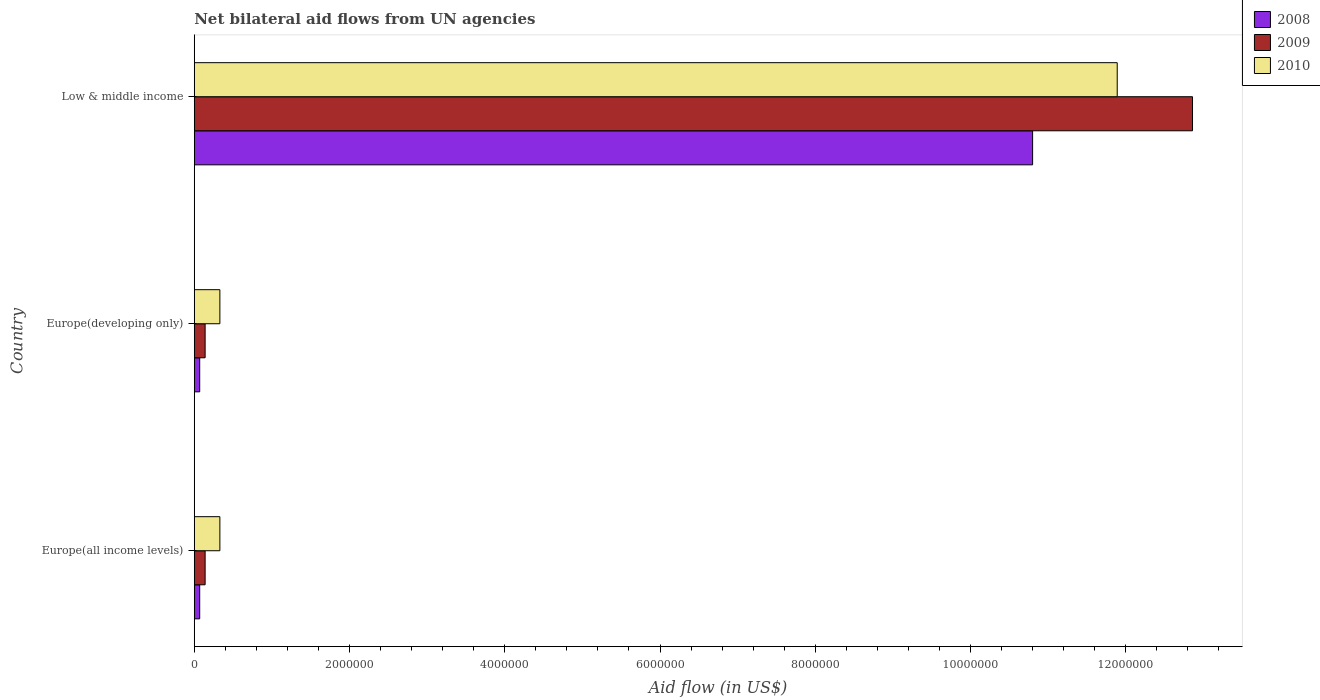Are the number of bars on each tick of the Y-axis equal?
Your answer should be compact. Yes. How many bars are there on the 1st tick from the bottom?
Provide a succinct answer. 3. What is the label of the 2nd group of bars from the top?
Keep it short and to the point. Europe(developing only). Across all countries, what is the maximum net bilateral aid flow in 2008?
Give a very brief answer. 1.08e+07. Across all countries, what is the minimum net bilateral aid flow in 2010?
Your answer should be compact. 3.30e+05. In which country was the net bilateral aid flow in 2009 minimum?
Offer a terse response. Europe(all income levels). What is the total net bilateral aid flow in 2009 in the graph?
Provide a short and direct response. 1.31e+07. What is the difference between the net bilateral aid flow in 2010 in Europe(developing only) and that in Low & middle income?
Make the answer very short. -1.16e+07. What is the difference between the net bilateral aid flow in 2008 in Europe(all income levels) and the net bilateral aid flow in 2009 in Low & middle income?
Offer a very short reply. -1.28e+07. What is the average net bilateral aid flow in 2009 per country?
Provide a succinct answer. 4.38e+06. What is the difference between the net bilateral aid flow in 2008 and net bilateral aid flow in 2010 in Low & middle income?
Ensure brevity in your answer.  -1.09e+06. In how many countries, is the net bilateral aid flow in 2009 greater than 11200000 US$?
Ensure brevity in your answer.  1. What is the ratio of the net bilateral aid flow in 2008 in Europe(all income levels) to that in Low & middle income?
Give a very brief answer. 0.01. Is the net bilateral aid flow in 2010 in Europe(all income levels) less than that in Low & middle income?
Keep it short and to the point. Yes. What is the difference between the highest and the second highest net bilateral aid flow in 2008?
Your answer should be very brief. 1.07e+07. What is the difference between the highest and the lowest net bilateral aid flow in 2009?
Provide a short and direct response. 1.27e+07. Is it the case that in every country, the sum of the net bilateral aid flow in 2010 and net bilateral aid flow in 2008 is greater than the net bilateral aid flow in 2009?
Give a very brief answer. Yes. Are all the bars in the graph horizontal?
Make the answer very short. Yes. Does the graph contain any zero values?
Your response must be concise. No. Where does the legend appear in the graph?
Provide a short and direct response. Top right. What is the title of the graph?
Keep it short and to the point. Net bilateral aid flows from UN agencies. What is the label or title of the X-axis?
Your answer should be compact. Aid flow (in US$). What is the label or title of the Y-axis?
Offer a very short reply. Country. What is the Aid flow (in US$) of 2008 in Europe(all income levels)?
Offer a very short reply. 7.00e+04. What is the Aid flow (in US$) of 2009 in Europe(all income levels)?
Offer a very short reply. 1.40e+05. What is the Aid flow (in US$) in 2010 in Europe(all income levels)?
Provide a succinct answer. 3.30e+05. What is the Aid flow (in US$) in 2009 in Europe(developing only)?
Give a very brief answer. 1.40e+05. What is the Aid flow (in US$) in 2010 in Europe(developing only)?
Make the answer very short. 3.30e+05. What is the Aid flow (in US$) in 2008 in Low & middle income?
Your response must be concise. 1.08e+07. What is the Aid flow (in US$) in 2009 in Low & middle income?
Make the answer very short. 1.29e+07. What is the Aid flow (in US$) of 2010 in Low & middle income?
Your answer should be very brief. 1.19e+07. Across all countries, what is the maximum Aid flow (in US$) in 2008?
Offer a terse response. 1.08e+07. Across all countries, what is the maximum Aid flow (in US$) of 2009?
Ensure brevity in your answer.  1.29e+07. Across all countries, what is the maximum Aid flow (in US$) in 2010?
Give a very brief answer. 1.19e+07. Across all countries, what is the minimum Aid flow (in US$) in 2010?
Offer a very short reply. 3.30e+05. What is the total Aid flow (in US$) in 2008 in the graph?
Offer a very short reply. 1.09e+07. What is the total Aid flow (in US$) of 2009 in the graph?
Give a very brief answer. 1.31e+07. What is the total Aid flow (in US$) in 2010 in the graph?
Offer a terse response. 1.26e+07. What is the difference between the Aid flow (in US$) in 2009 in Europe(all income levels) and that in Europe(developing only)?
Offer a very short reply. 0. What is the difference between the Aid flow (in US$) of 2008 in Europe(all income levels) and that in Low & middle income?
Your answer should be compact. -1.07e+07. What is the difference between the Aid flow (in US$) in 2009 in Europe(all income levels) and that in Low & middle income?
Keep it short and to the point. -1.27e+07. What is the difference between the Aid flow (in US$) in 2010 in Europe(all income levels) and that in Low & middle income?
Offer a terse response. -1.16e+07. What is the difference between the Aid flow (in US$) of 2008 in Europe(developing only) and that in Low & middle income?
Your response must be concise. -1.07e+07. What is the difference between the Aid flow (in US$) in 2009 in Europe(developing only) and that in Low & middle income?
Ensure brevity in your answer.  -1.27e+07. What is the difference between the Aid flow (in US$) of 2010 in Europe(developing only) and that in Low & middle income?
Your response must be concise. -1.16e+07. What is the difference between the Aid flow (in US$) of 2008 in Europe(all income levels) and the Aid flow (in US$) of 2009 in Europe(developing only)?
Provide a short and direct response. -7.00e+04. What is the difference between the Aid flow (in US$) of 2008 in Europe(all income levels) and the Aid flow (in US$) of 2010 in Europe(developing only)?
Provide a short and direct response. -2.60e+05. What is the difference between the Aid flow (in US$) of 2008 in Europe(all income levels) and the Aid flow (in US$) of 2009 in Low & middle income?
Offer a very short reply. -1.28e+07. What is the difference between the Aid flow (in US$) in 2008 in Europe(all income levels) and the Aid flow (in US$) in 2010 in Low & middle income?
Your answer should be very brief. -1.18e+07. What is the difference between the Aid flow (in US$) in 2009 in Europe(all income levels) and the Aid flow (in US$) in 2010 in Low & middle income?
Your answer should be very brief. -1.18e+07. What is the difference between the Aid flow (in US$) of 2008 in Europe(developing only) and the Aid flow (in US$) of 2009 in Low & middle income?
Provide a short and direct response. -1.28e+07. What is the difference between the Aid flow (in US$) in 2008 in Europe(developing only) and the Aid flow (in US$) in 2010 in Low & middle income?
Provide a short and direct response. -1.18e+07. What is the difference between the Aid flow (in US$) in 2009 in Europe(developing only) and the Aid flow (in US$) in 2010 in Low & middle income?
Ensure brevity in your answer.  -1.18e+07. What is the average Aid flow (in US$) in 2008 per country?
Your answer should be compact. 3.65e+06. What is the average Aid flow (in US$) in 2009 per country?
Ensure brevity in your answer.  4.38e+06. What is the average Aid flow (in US$) of 2010 per country?
Your answer should be very brief. 4.18e+06. What is the difference between the Aid flow (in US$) in 2008 and Aid flow (in US$) in 2009 in Europe(all income levels)?
Ensure brevity in your answer.  -7.00e+04. What is the difference between the Aid flow (in US$) of 2008 and Aid flow (in US$) of 2010 in Europe(developing only)?
Ensure brevity in your answer.  -2.60e+05. What is the difference between the Aid flow (in US$) of 2008 and Aid flow (in US$) of 2009 in Low & middle income?
Your response must be concise. -2.06e+06. What is the difference between the Aid flow (in US$) of 2008 and Aid flow (in US$) of 2010 in Low & middle income?
Offer a terse response. -1.09e+06. What is the difference between the Aid flow (in US$) of 2009 and Aid flow (in US$) of 2010 in Low & middle income?
Make the answer very short. 9.70e+05. What is the ratio of the Aid flow (in US$) of 2008 in Europe(all income levels) to that in Low & middle income?
Give a very brief answer. 0.01. What is the ratio of the Aid flow (in US$) in 2009 in Europe(all income levels) to that in Low & middle income?
Offer a terse response. 0.01. What is the ratio of the Aid flow (in US$) of 2010 in Europe(all income levels) to that in Low & middle income?
Your answer should be very brief. 0.03. What is the ratio of the Aid flow (in US$) of 2008 in Europe(developing only) to that in Low & middle income?
Make the answer very short. 0.01. What is the ratio of the Aid flow (in US$) in 2009 in Europe(developing only) to that in Low & middle income?
Make the answer very short. 0.01. What is the ratio of the Aid flow (in US$) of 2010 in Europe(developing only) to that in Low & middle income?
Provide a short and direct response. 0.03. What is the difference between the highest and the second highest Aid flow (in US$) of 2008?
Make the answer very short. 1.07e+07. What is the difference between the highest and the second highest Aid flow (in US$) in 2009?
Provide a succinct answer. 1.27e+07. What is the difference between the highest and the second highest Aid flow (in US$) in 2010?
Provide a short and direct response. 1.16e+07. What is the difference between the highest and the lowest Aid flow (in US$) of 2008?
Your answer should be compact. 1.07e+07. What is the difference between the highest and the lowest Aid flow (in US$) in 2009?
Offer a terse response. 1.27e+07. What is the difference between the highest and the lowest Aid flow (in US$) in 2010?
Your answer should be compact. 1.16e+07. 